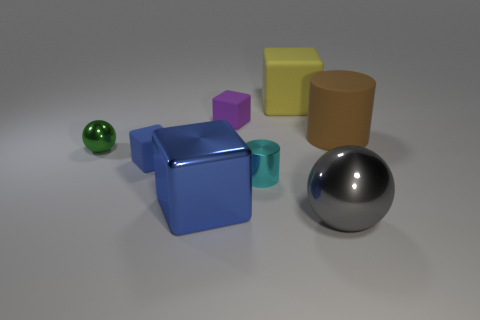Subtract 1 blocks. How many blocks are left? 3 Subtract all red blocks. Subtract all brown cylinders. How many blocks are left? 4 Add 2 gray objects. How many objects exist? 10 Subtract all cylinders. How many objects are left? 6 Add 1 shiny things. How many shiny things exist? 5 Subtract 0 purple cylinders. How many objects are left? 8 Subtract all cylinders. Subtract all tiny shiny cylinders. How many objects are left? 5 Add 1 purple rubber objects. How many purple rubber objects are left? 2 